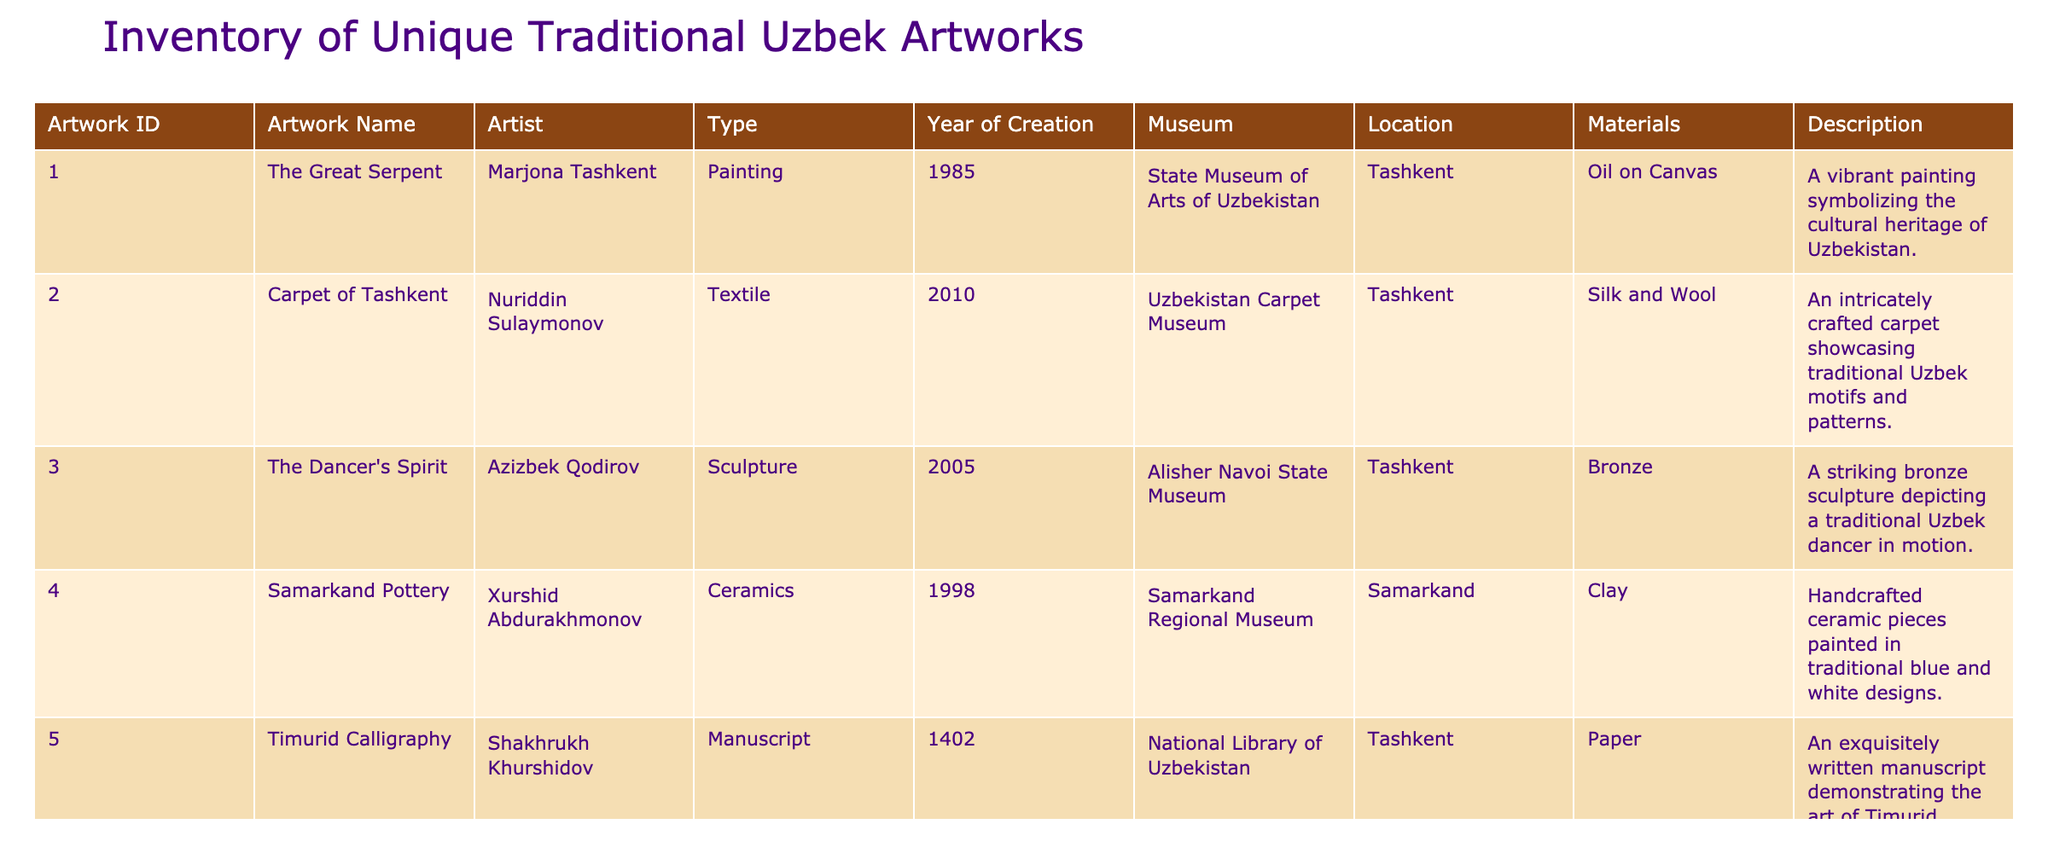What is the name of the artwork created by Nuriddin Sulaymonov? The table lists the artist Nuriddin Sulaymonov under the artwork titled "Carpet of Tashkent."
Answer: Carpet of Tashkent Which museum houses the "Timurid Calligraphy"? The table shows that the "Timurid Calligraphy" artwork is located at the National Library of Uzbekistan.
Answer: National Library of Uzbekistan How many artworks were created after the year 2000? From the table, the artworks that were created after 2000 are: "Carpet of Tashkent" (2010), "The Dancer's Spirit" (2005), "Heritage of Bukhara" (2020), and "The Silk Road Journey" (2018), totaling to 4 artworks.
Answer: 4 Is "The Great Serpent" a sculpture? The table indicates that "The Great Serpent" is categorized as a painting, thus making the statement false.
Answer: No Which artwork uses mixed media and what year was it created? The table reveals that "The Silk Road Journey" is a multimedia installation created in the year 2018.
Answer: The Silk Road Journey, 2018 What materials are used in the "Samarkand Pottery"? The table describes that the "Samarkand Pottery" is made of clay.
Answer: Clay What is the average year of creation for the artworks in the inventory? The years of creation for the artworks are: 1985, 2010, 2005, 1998, 1402, 2018, 1975, 2020. Their sum is 1993, and with 8 artworks, the average is 1993/8, which is approximately 249.125. Therefore, the average year of creation is 249 when rounded down.
Answer: 249 Which city has the most artworks represented in this inventory? Analyzing the table, Tashkent features 4 artworks ("The Great Serpent," "Carpet of Tashkent," "The Dancer's Spirit," and "The Silk Road Journey"), while Samarkand has 2, Bukhara has 1, and there is 1 from the National Library. Tashkent has the most.
Answer: Tashkent 